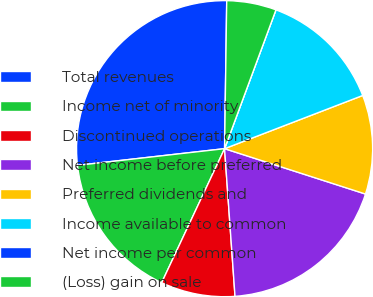<chart> <loc_0><loc_0><loc_500><loc_500><pie_chart><fcel>Total revenues<fcel>Income net of minority<fcel>Discontinued operations<fcel>Net income before preferred<fcel>Preferred dividends and<fcel>Income available to common<fcel>Net income per common<fcel>(Loss) gain on sale<nl><fcel>27.03%<fcel>16.22%<fcel>8.11%<fcel>18.92%<fcel>10.81%<fcel>13.51%<fcel>0.0%<fcel>5.41%<nl></chart> 